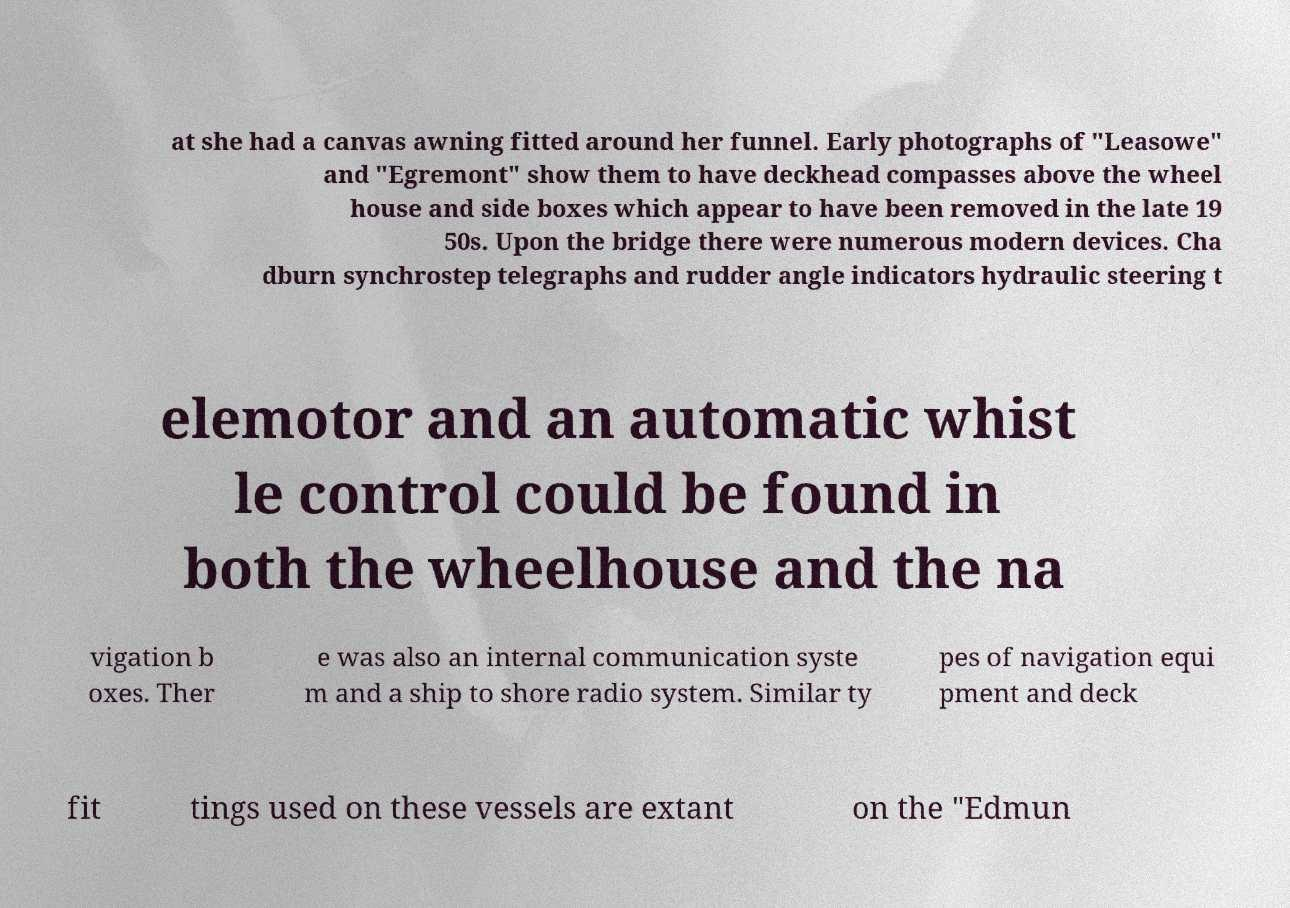Could you extract and type out the text from this image? at she had a canvas awning fitted around her funnel. Early photographs of "Leasowe" and "Egremont" show them to have deckhead compasses above the wheel house and side boxes which appear to have been removed in the late 19 50s. Upon the bridge there were numerous modern devices. Cha dburn synchrostep telegraphs and rudder angle indicators hydraulic steering t elemotor and an automatic whist le control could be found in both the wheelhouse and the na vigation b oxes. Ther e was also an internal communication syste m and a ship to shore radio system. Similar ty pes of navigation equi pment and deck fit tings used on these vessels are extant on the "Edmun 